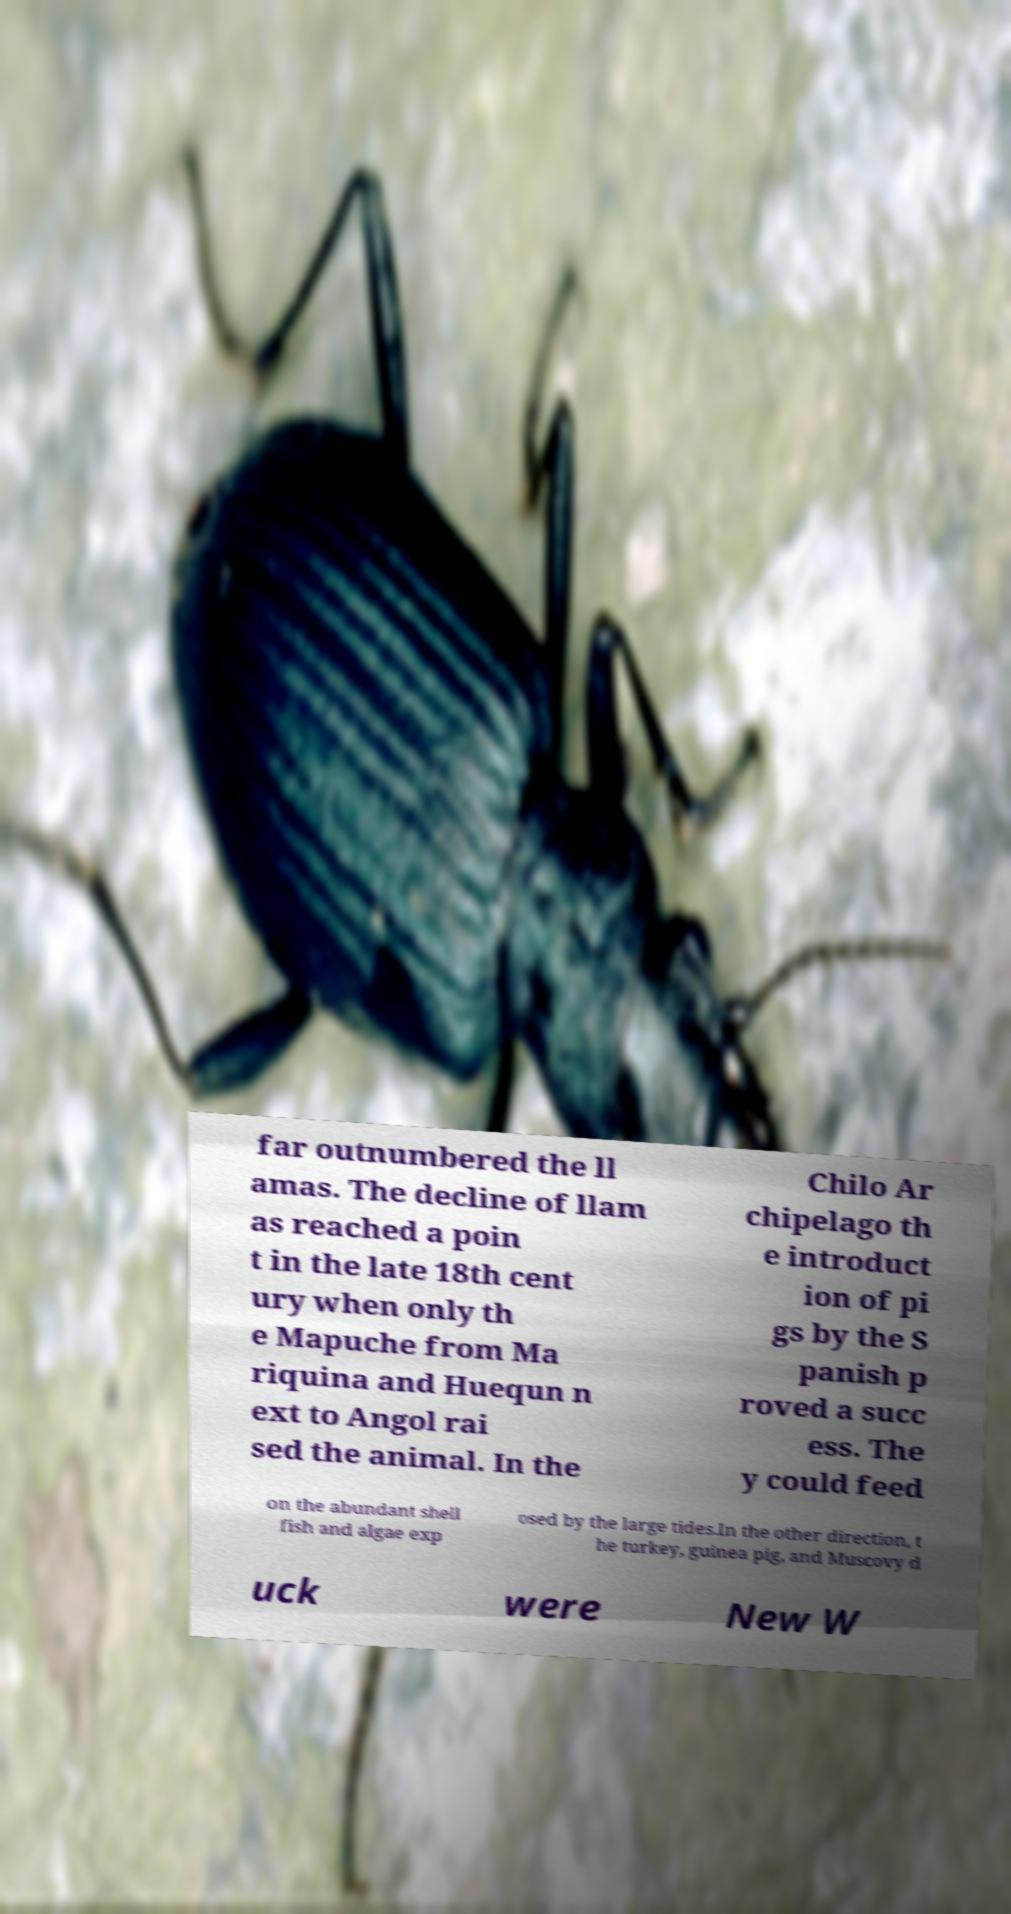Please identify and transcribe the text found in this image. far outnumbered the ll amas. The decline of llam as reached a poin t in the late 18th cent ury when only th e Mapuche from Ma riquina and Huequn n ext to Angol rai sed the animal. In the Chilo Ar chipelago th e introduct ion of pi gs by the S panish p roved a succ ess. The y could feed on the abundant shell fish and algae exp osed by the large tides.In the other direction, t he turkey, guinea pig, and Muscovy d uck were New W 